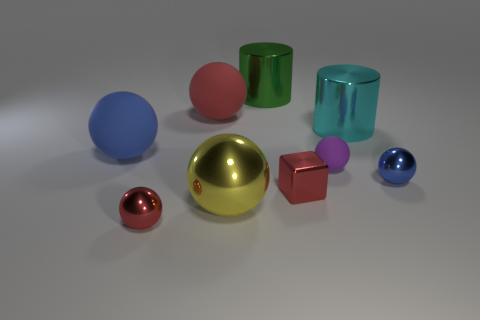Are there more yellow metallic balls that are behind the purple rubber sphere than small yellow metal blocks?
Provide a short and direct response. No. How many things are either yellow objects that are in front of the purple matte thing or tiny blue cylinders?
Your answer should be very brief. 1. What number of spheres have the same material as the large green thing?
Your answer should be compact. 3. The small metallic object that is the same color as the cube is what shape?
Provide a short and direct response. Sphere. Are there any tiny blue things of the same shape as the cyan shiny thing?
Ensure brevity in your answer.  No. What shape is the green object that is the same size as the yellow metallic thing?
Provide a succinct answer. Cylinder. Does the tiny rubber ball have the same color as the big metallic cylinder that is right of the green object?
Your answer should be very brief. No. What number of blue metal balls are behind the large cyan metal cylinder that is in front of the red rubber object?
Provide a short and direct response. 0. There is a metallic ball that is both on the left side of the blue metal object and right of the large red object; what size is it?
Provide a succinct answer. Large. Are there any rubber balls that have the same size as the cyan metal object?
Ensure brevity in your answer.  Yes. 